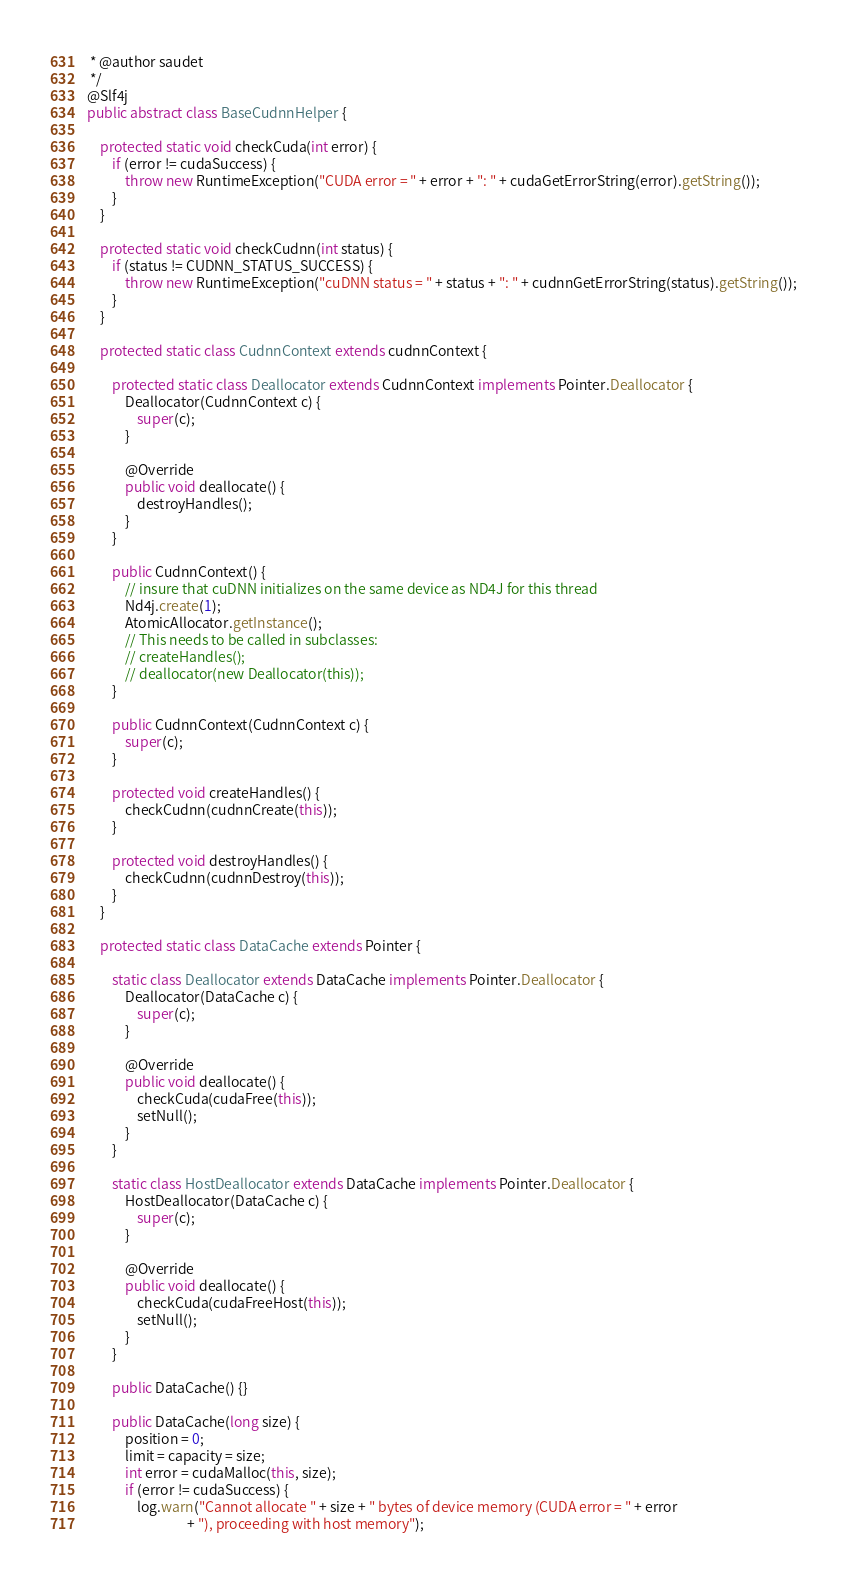Convert code to text. <code><loc_0><loc_0><loc_500><loc_500><_Java_> * @author saudet
 */
@Slf4j
public abstract class BaseCudnnHelper {

    protected static void checkCuda(int error) {
        if (error != cudaSuccess) {
            throw new RuntimeException("CUDA error = " + error + ": " + cudaGetErrorString(error).getString());
        }
    }

    protected static void checkCudnn(int status) {
        if (status != CUDNN_STATUS_SUCCESS) {
            throw new RuntimeException("cuDNN status = " + status + ": " + cudnnGetErrorString(status).getString());
        }
    }

    protected static class CudnnContext extends cudnnContext {

        protected static class Deallocator extends CudnnContext implements Pointer.Deallocator {
            Deallocator(CudnnContext c) {
                super(c);
            }

            @Override
            public void deallocate() {
                destroyHandles();
            }
        }

        public CudnnContext() {
            // insure that cuDNN initializes on the same device as ND4J for this thread
            Nd4j.create(1);
            AtomicAllocator.getInstance();
            // This needs to be called in subclasses:
            // createHandles();
            // deallocator(new Deallocator(this));
        }

        public CudnnContext(CudnnContext c) {
            super(c);
        }

        protected void createHandles() {
            checkCudnn(cudnnCreate(this));
        }

        protected void destroyHandles() {
            checkCudnn(cudnnDestroy(this));
        }
    }

    protected static class DataCache extends Pointer {

        static class Deallocator extends DataCache implements Pointer.Deallocator {
            Deallocator(DataCache c) {
                super(c);
            }

            @Override
            public void deallocate() {
                checkCuda(cudaFree(this));
                setNull();
            }
        }

        static class HostDeallocator extends DataCache implements Pointer.Deallocator {
            HostDeallocator(DataCache c) {
                super(c);
            }

            @Override
            public void deallocate() {
                checkCuda(cudaFreeHost(this));
                setNull();
            }
        }

        public DataCache() {}

        public DataCache(long size) {
            position = 0;
            limit = capacity = size;
            int error = cudaMalloc(this, size);
            if (error != cudaSuccess) {
                log.warn("Cannot allocate " + size + " bytes of device memory (CUDA error = " + error
                                + "), proceeding with host memory");</code> 